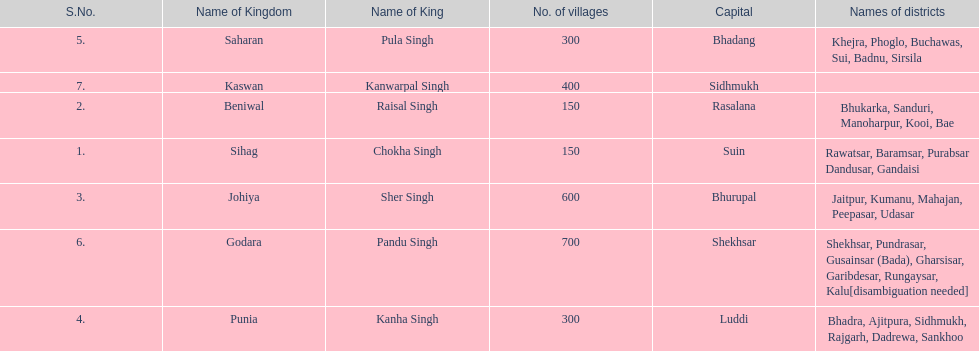How many kingdoms are listed? 7. 